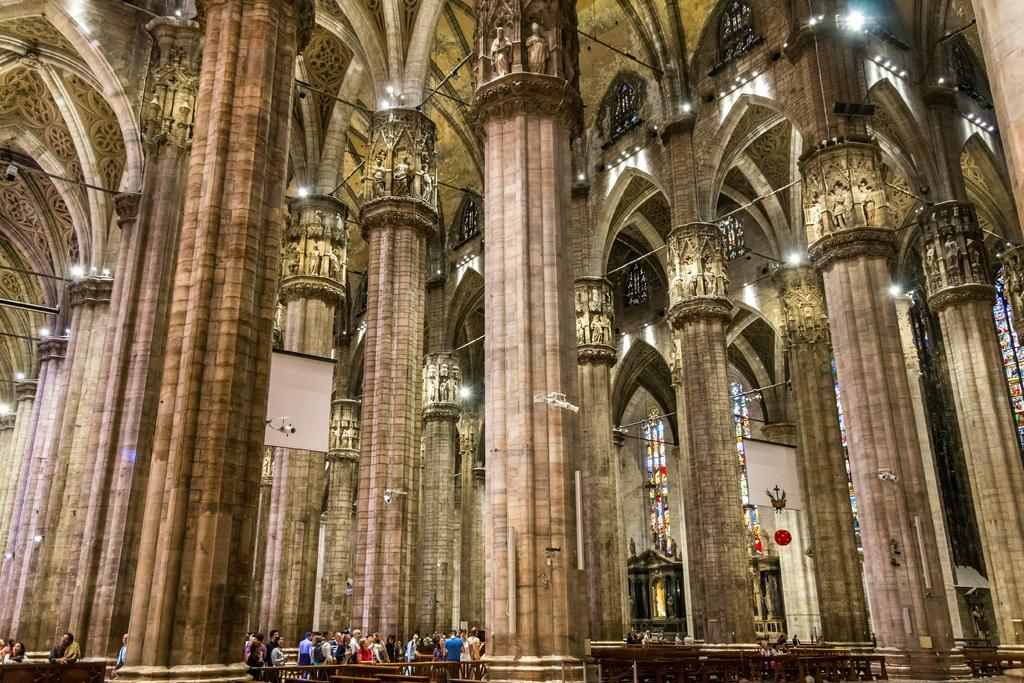What is happening in the foreground of the image? There are people standing in front of a table. Can you describe the setting of the image? There is a building in the background of the image. What type of tree is growing in the middle of the table? There is no tree present on the table in the image. What verse can be heard being recited by the people in the image? There is no indication of any verse being recited in the image. 